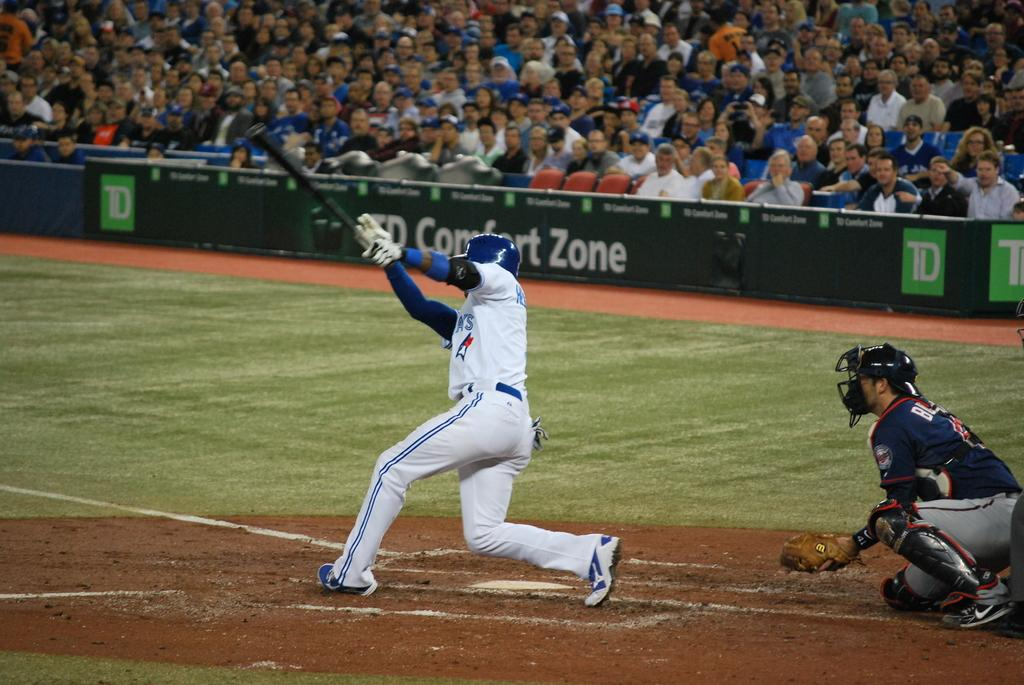<image>
Offer a succinct explanation of the picture presented. batter swinging his bat with td comfort zone signage in background 